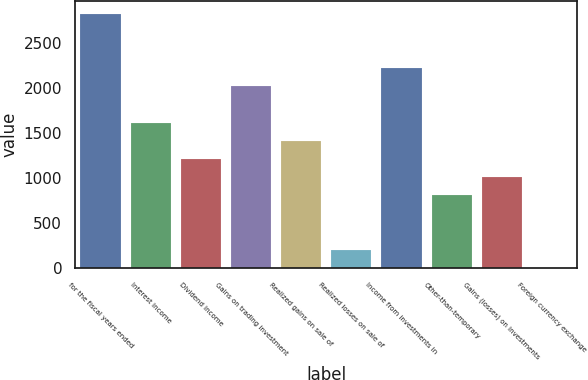<chart> <loc_0><loc_0><loc_500><loc_500><bar_chart><fcel>for the fiscal years ended<fcel>Interest income<fcel>Dividend income<fcel>Gains on trading investment<fcel>Realized gains on sale of<fcel>Realized losses on sale of<fcel>Income from investments in<fcel>Other-than-temporary<fcel>Gains (losses) on investments<fcel>Foreign currency exchange<nl><fcel>2821.24<fcel>1613.38<fcel>1210.76<fcel>2016<fcel>1412.07<fcel>204.21<fcel>2217.31<fcel>808.14<fcel>1009.45<fcel>2.9<nl></chart> 